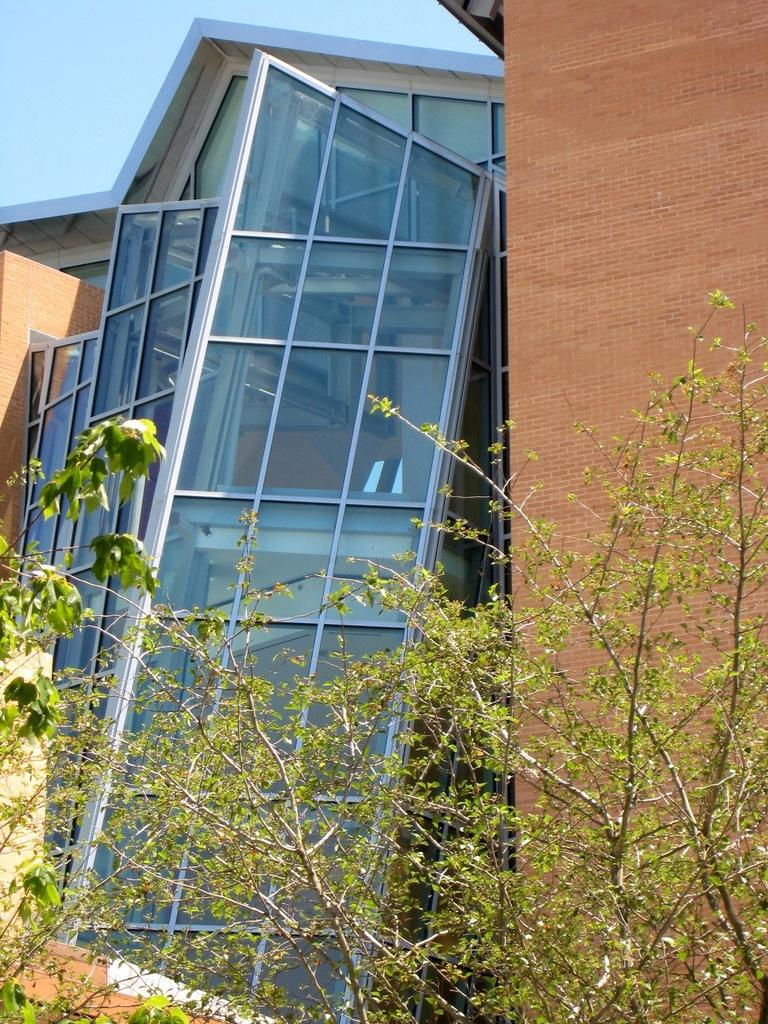What type of vegetation is present at the bottom of the image? There are plants at the bottom side of the image. What type of structure can be seen in the background of the image? There is a skyscraper in the background area of the image. How much income does the hen generate from the oil in the image? There is no hen or oil present in the image, so this question cannot be answered. 